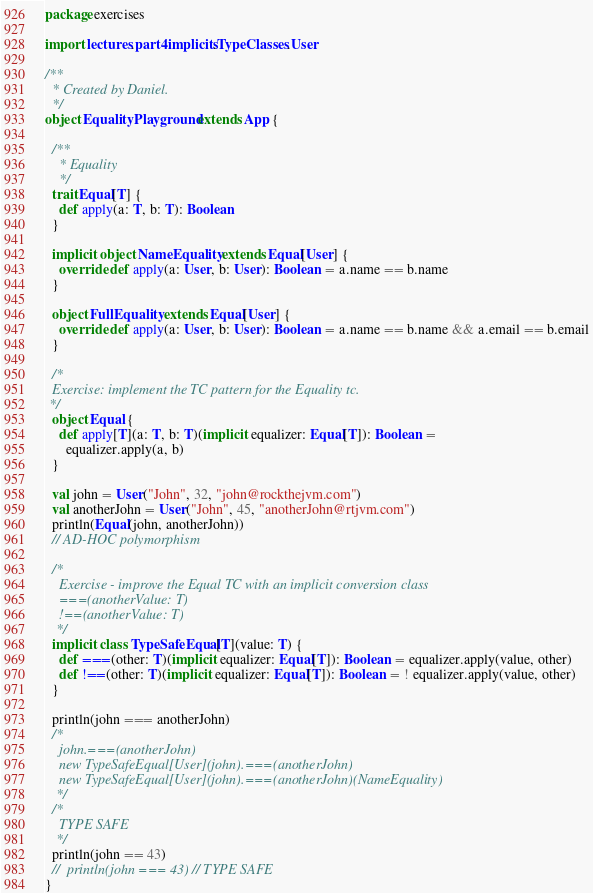Convert code to text. <code><loc_0><loc_0><loc_500><loc_500><_Scala_>package exercises

import lectures.part4implicits.TypeClasses.User

/**
  * Created by Daniel.
  */
object EqualityPlayground extends App {

  /**
    * Equality
    */
  trait Equal[T] {
    def apply(a: T, b: T): Boolean
  }

  implicit object NameEquality extends Equal[User] {
    override def apply(a: User, b: User): Boolean = a.name == b.name
  }

  object FullEquality extends Equal[User] {
    override def apply(a: User, b: User): Boolean = a.name == b.name && a.email == b.email
  }

  /*
  Exercise: implement the TC pattern for the Equality tc.
 */
  object Equal {
    def apply[T](a: T, b: T)(implicit equalizer: Equal[T]): Boolean =
      equalizer.apply(a, b)
  }

  val john = User("John", 32, "john@rockthejvm.com")
  val anotherJohn = User("John", 45, "anotherJohn@rtjvm.com")
  println(Equal(john, anotherJohn))
  // AD-HOC polymorphism

  /*
    Exercise - improve the Equal TC with an implicit conversion class
    ===(anotherValue: T)
    !==(anotherValue: T)
   */
  implicit class TypeSafeEqual[T](value: T) {
    def ===(other: T)(implicit equalizer: Equal[T]): Boolean = equalizer.apply(value, other)
    def !==(other: T)(implicit equalizer: Equal[T]): Boolean = ! equalizer.apply(value, other)
  }

  println(john === anotherJohn)
  /*
    john.===(anotherJohn)
    new TypeSafeEqual[User](john).===(anotherJohn)
    new TypeSafeEqual[User](john).===(anotherJohn)(NameEquality)
   */
  /*
    TYPE SAFE
   */
  println(john == 43)
  //  println(john === 43) // TYPE SAFE
}
</code> 